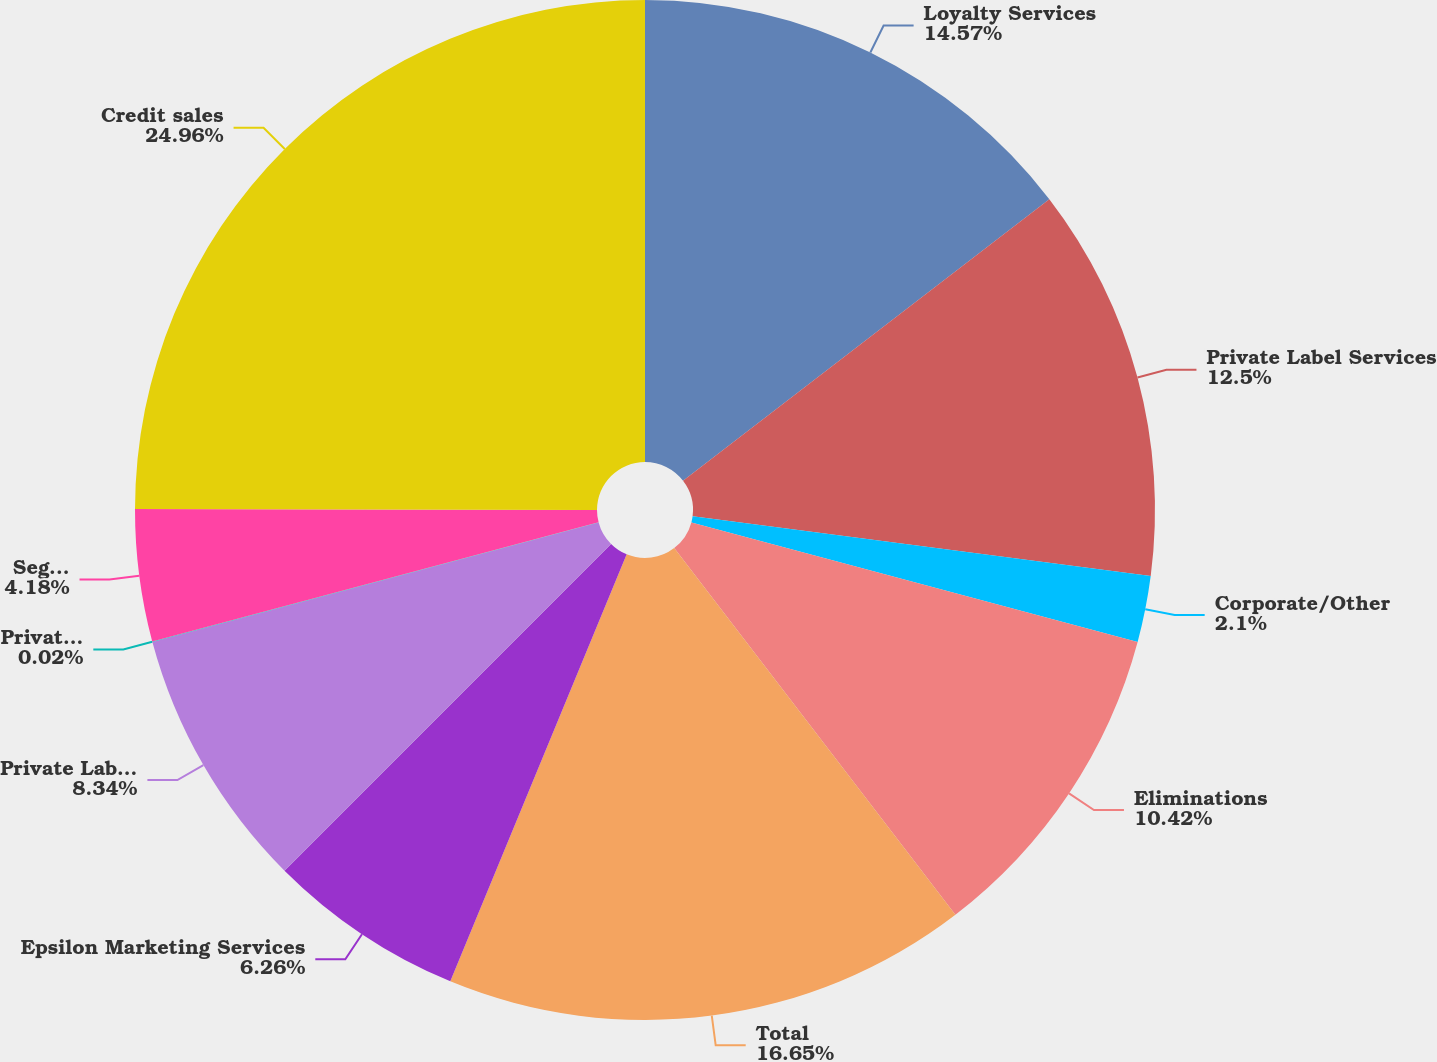Convert chart. <chart><loc_0><loc_0><loc_500><loc_500><pie_chart><fcel>Loyalty Services<fcel>Private Label Services<fcel>Corporate/Other<fcel>Eliminations<fcel>Total<fcel>Epsilon Marketing Services<fcel>Private Label Credit<fcel>Private Label Services Private<fcel>Segment operating data Private<fcel>Credit sales<nl><fcel>14.57%<fcel>12.5%<fcel>2.1%<fcel>10.42%<fcel>16.65%<fcel>6.26%<fcel>8.34%<fcel>0.02%<fcel>4.18%<fcel>24.97%<nl></chart> 